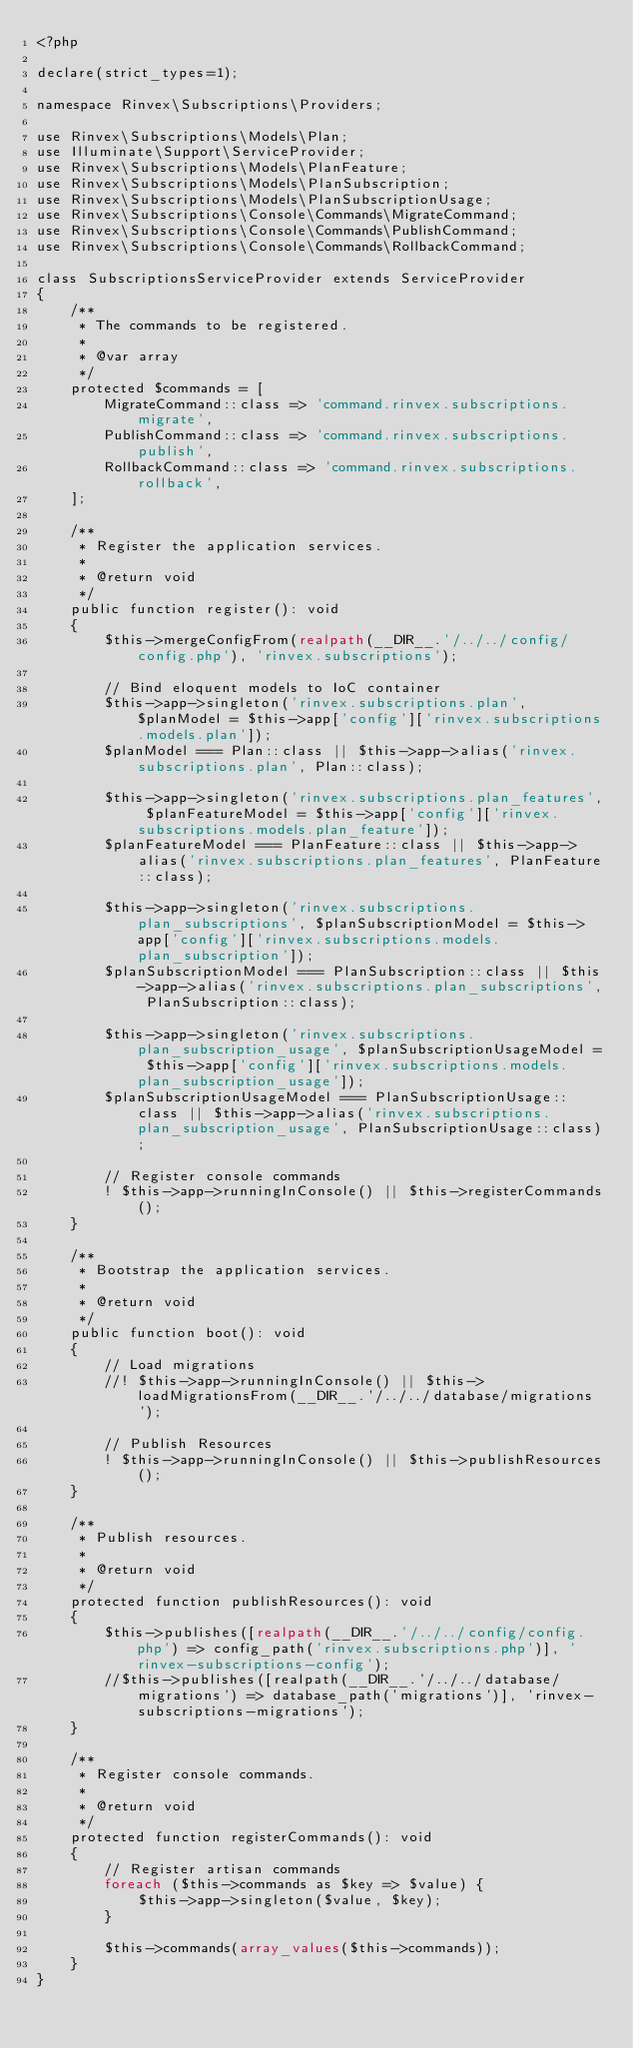<code> <loc_0><loc_0><loc_500><loc_500><_PHP_><?php

declare(strict_types=1);

namespace Rinvex\Subscriptions\Providers;

use Rinvex\Subscriptions\Models\Plan;
use Illuminate\Support\ServiceProvider;
use Rinvex\Subscriptions\Models\PlanFeature;
use Rinvex\Subscriptions\Models\PlanSubscription;
use Rinvex\Subscriptions\Models\PlanSubscriptionUsage;
use Rinvex\Subscriptions\Console\Commands\MigrateCommand;
use Rinvex\Subscriptions\Console\Commands\PublishCommand;
use Rinvex\Subscriptions\Console\Commands\RollbackCommand;

class SubscriptionsServiceProvider extends ServiceProvider
{
    /**
     * The commands to be registered.
     *
     * @var array
     */
    protected $commands = [
        MigrateCommand::class => 'command.rinvex.subscriptions.migrate',
        PublishCommand::class => 'command.rinvex.subscriptions.publish',
        RollbackCommand::class => 'command.rinvex.subscriptions.rollback',
    ];

    /**
     * Register the application services.
     *
     * @return void
     */
    public function register(): void
    {
        $this->mergeConfigFrom(realpath(__DIR__.'/../../config/config.php'), 'rinvex.subscriptions');

        // Bind eloquent models to IoC container
        $this->app->singleton('rinvex.subscriptions.plan', $planModel = $this->app['config']['rinvex.subscriptions.models.plan']);
        $planModel === Plan::class || $this->app->alias('rinvex.subscriptions.plan', Plan::class);

        $this->app->singleton('rinvex.subscriptions.plan_features', $planFeatureModel = $this->app['config']['rinvex.subscriptions.models.plan_feature']);
        $planFeatureModel === PlanFeature::class || $this->app->alias('rinvex.subscriptions.plan_features', PlanFeature::class);

        $this->app->singleton('rinvex.subscriptions.plan_subscriptions', $planSubscriptionModel = $this->app['config']['rinvex.subscriptions.models.plan_subscription']);
        $planSubscriptionModel === PlanSubscription::class || $this->app->alias('rinvex.subscriptions.plan_subscriptions', PlanSubscription::class);

        $this->app->singleton('rinvex.subscriptions.plan_subscription_usage', $planSubscriptionUsageModel = $this->app['config']['rinvex.subscriptions.models.plan_subscription_usage']);
        $planSubscriptionUsageModel === PlanSubscriptionUsage::class || $this->app->alias('rinvex.subscriptions.plan_subscription_usage', PlanSubscriptionUsage::class);

        // Register console commands
        ! $this->app->runningInConsole() || $this->registerCommands();
    }

    /**
     * Bootstrap the application services.
     *
     * @return void
     */
    public function boot(): void
    {
        // Load migrations
        //! $this->app->runningInConsole() || $this->loadMigrationsFrom(__DIR__.'/../../database/migrations');

        // Publish Resources
        ! $this->app->runningInConsole() || $this->publishResources();
    }

    /**
     * Publish resources.
     *
     * @return void
     */
    protected function publishResources(): void
    {
        $this->publishes([realpath(__DIR__.'/../../config/config.php') => config_path('rinvex.subscriptions.php')], 'rinvex-subscriptions-config');
        //$this->publishes([realpath(__DIR__.'/../../database/migrations') => database_path('migrations')], 'rinvex-subscriptions-migrations');
    }

    /**
     * Register console commands.
     *
     * @return void
     */
    protected function registerCommands(): void
    {
        // Register artisan commands
        foreach ($this->commands as $key => $value) {
            $this->app->singleton($value, $key);
        }

        $this->commands(array_values($this->commands));
    }
}
</code> 